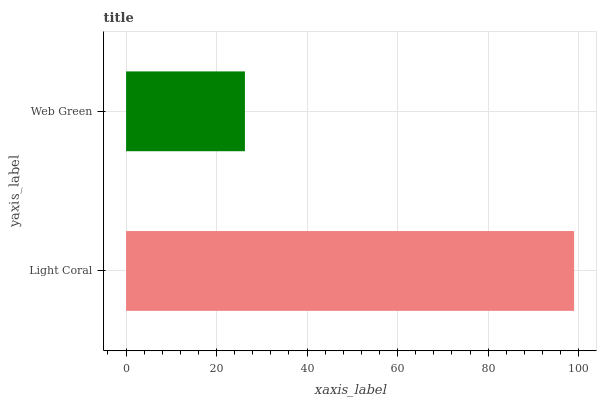Is Web Green the minimum?
Answer yes or no. Yes. Is Light Coral the maximum?
Answer yes or no. Yes. Is Web Green the maximum?
Answer yes or no. No. Is Light Coral greater than Web Green?
Answer yes or no. Yes. Is Web Green less than Light Coral?
Answer yes or no. Yes. Is Web Green greater than Light Coral?
Answer yes or no. No. Is Light Coral less than Web Green?
Answer yes or no. No. Is Light Coral the high median?
Answer yes or no. Yes. Is Web Green the low median?
Answer yes or no. Yes. Is Web Green the high median?
Answer yes or no. No. Is Light Coral the low median?
Answer yes or no. No. 